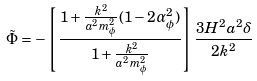Convert formula to latex. <formula><loc_0><loc_0><loc_500><loc_500>\tilde { \Phi } = - \left [ \frac { 1 + \frac { k ^ { 2 } } { a ^ { 2 } m _ { \phi } ^ { 2 } } ( 1 - 2 \alpha _ { \phi } ^ { 2 } ) } { 1 + \frac { k ^ { 2 } } { a ^ { 2 } m _ { \phi } ^ { 2 } } } \right ] \frac { 3 H ^ { 2 } a ^ { 2 } \delta } { 2 k ^ { 2 } }</formula> 